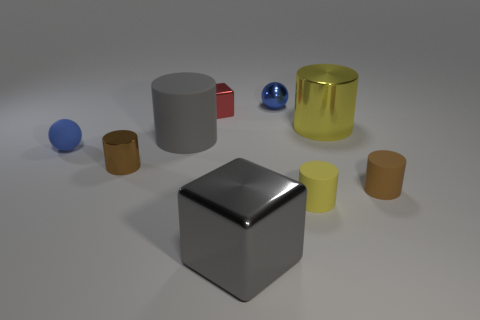What number of other things are the same size as the red metal cube?
Your response must be concise. 5. There is a blue rubber sphere in front of the large yellow object; is its size the same as the brown object that is on the left side of the small metallic ball?
Give a very brief answer. Yes. How many objects are big purple rubber blocks or metallic objects behind the large gray metallic thing?
Provide a short and direct response. 4. There is a matte cylinder that is to the left of the large metal cube; how big is it?
Your response must be concise. Large. Is the number of yellow shiny cylinders that are left of the small red thing less than the number of rubber spheres in front of the large rubber cylinder?
Provide a short and direct response. Yes. There is a large object that is on the right side of the big gray rubber cylinder and behind the tiny yellow matte object; what material is it?
Keep it short and to the point. Metal. The big shiny thing on the right side of the tiny matte cylinder that is in front of the brown matte cylinder is what shape?
Your answer should be compact. Cylinder. Is the tiny matte ball the same color as the small shiny ball?
Keep it short and to the point. Yes. How many yellow things are either metal cubes or cylinders?
Ensure brevity in your answer.  2. There is a gray metallic object; are there any matte things on the right side of it?
Your answer should be very brief. Yes. 